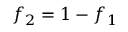<formula> <loc_0><loc_0><loc_500><loc_500>f _ { 2 } = 1 - f _ { 1 }</formula> 